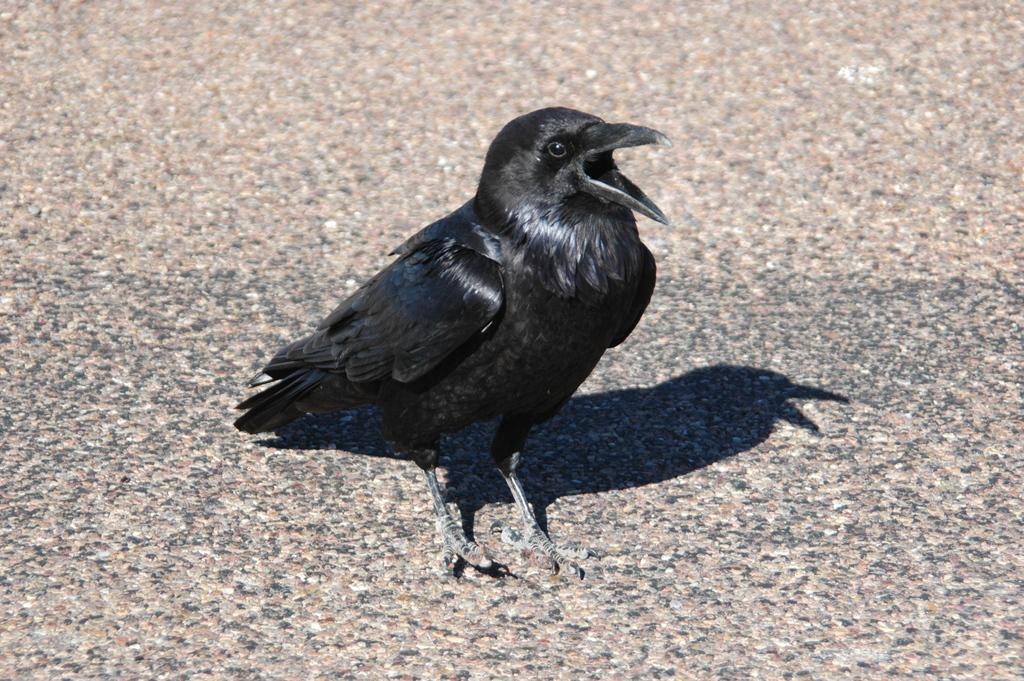What type of bird is in the image? There is a crow in the image. Is the crow in the image a slave to the other animals? There is no indication in the image that the crow is a slave to any other animals. Does the image show the crow believing in a particular idea or concept? The image does not provide any information about the crow's beliefs. 